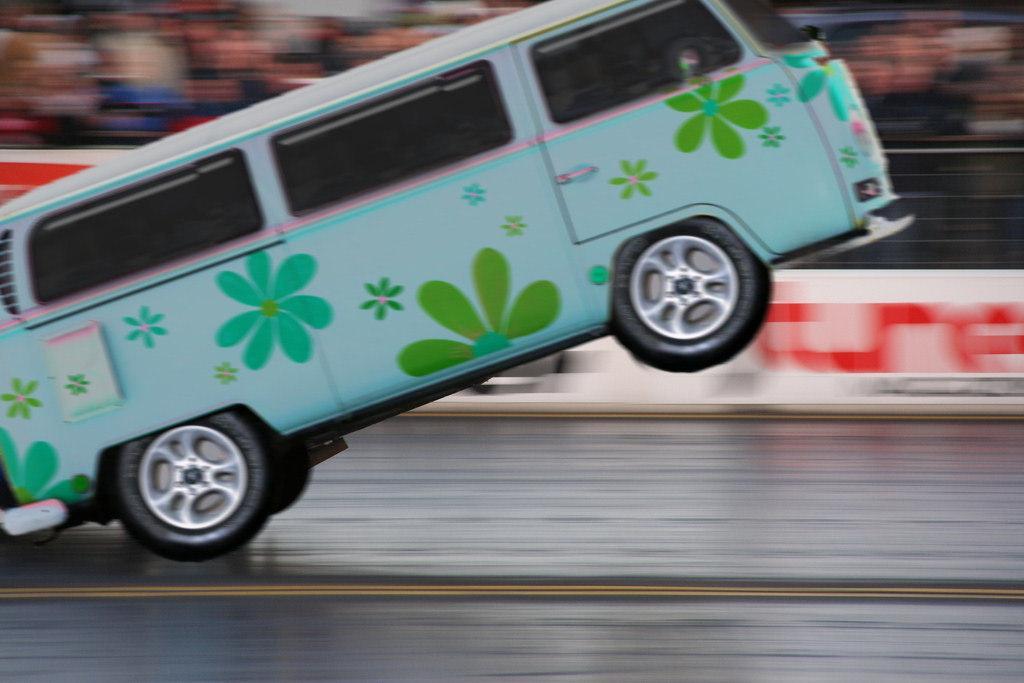How would you summarize this image in a sentence or two? In this image in front there is a vehicle on the road. Behind the vehicle there is a banner. There is a metal fence and the background of the image is blur. 